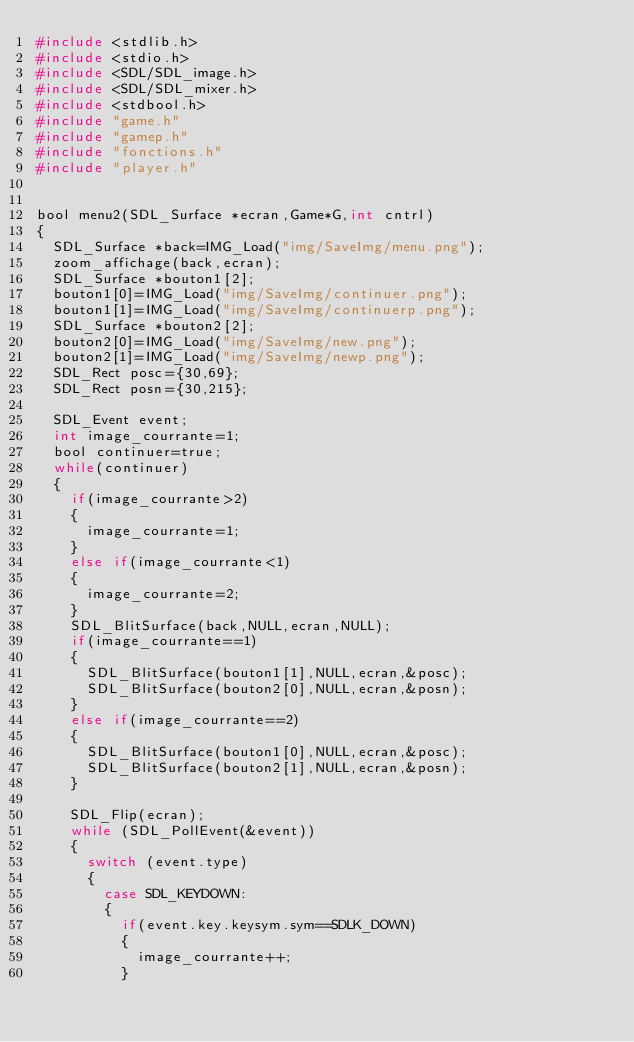<code> <loc_0><loc_0><loc_500><loc_500><_C_>#include <stdlib.h>
#include <stdio.h>
#include <SDL/SDL_image.h>
#include <SDL/SDL_mixer.h>
#include <stdbool.h>
#include "game.h"
#include "gamep.h"
#include "fonctions.h"
#include "player.h"


bool menu2(SDL_Surface *ecran,Game*G,int cntrl)
{
	SDL_Surface *back=IMG_Load("img/SaveImg/menu.png");
	zoom_affichage(back,ecran);
	SDL_Surface *bouton1[2];
	bouton1[0]=IMG_Load("img/SaveImg/continuer.png");
	bouton1[1]=IMG_Load("img/SaveImg/continuerp.png");
	SDL_Surface *bouton2[2];
	bouton2[0]=IMG_Load("img/SaveImg/new.png");
	bouton2[1]=IMG_Load("img/SaveImg/newp.png");
	SDL_Rect posc={30,69};
	SDL_Rect posn={30,215};

	SDL_Event event;
	int image_courrante=1;
	bool continuer=true;
	while(continuer)
	{
		if(image_courrante>2)
		{
			image_courrante=1;
		}
		else if(image_courrante<1)
		{
			image_courrante=2;
		}
		SDL_BlitSurface(back,NULL,ecran,NULL);
		if(image_courrante==1)
		{
			SDL_BlitSurface(bouton1[1],NULL,ecran,&posc);
			SDL_BlitSurface(bouton2[0],NULL,ecran,&posn);
		}
		else if(image_courrante==2)
		{
			SDL_BlitSurface(bouton1[0],NULL,ecran,&posc);
			SDL_BlitSurface(bouton2[1],NULL,ecran,&posn);
		}

		SDL_Flip(ecran);
		while (SDL_PollEvent(&event))
		{
			switch (event.type)
			{ 
				case SDL_KEYDOWN:
				{
					if(event.key.keysym.sym==SDLK_DOWN)
					{
						image_courrante++;
					}</code> 